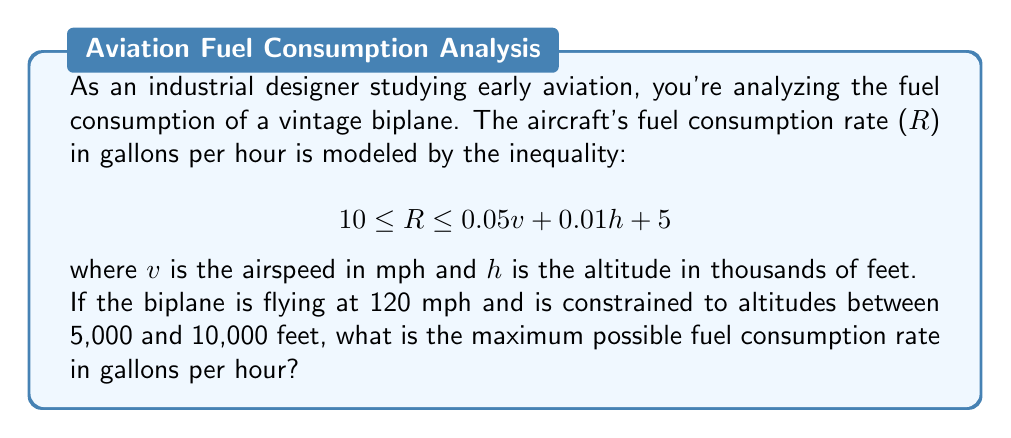Can you solve this math problem? To solve this problem, we need to follow these steps:

1) First, let's understand the given inequality:
   $$10 \leq R \leq 0.05v + 0.01h + 5$$

2) We're given that the airspeed $v = 120$ mph.

3) The altitude $h$ is between 5 and 10 thousand feet. To maximize fuel consumption, we should use the upper limit of 10,000 feet, or $h = 10$.

4) Let's substitute these values into the right side of the inequality:

   $$R \leq 0.05(120) + 0.01(10) + 5$$

5) Now let's calculate:
   
   $$R \leq 6 + 0.1 + 5$$
   $$R \leq 11.1$$

6) Remember, we also have the lower bound of 10 from the original inequality.

7) Therefore, the complete solution is:

   $$10 \leq R \leq 11.1$$

8) The question asks for the maximum possible fuel consumption rate, which is the upper bound of this inequality.
Answer: The maximum possible fuel consumption rate is 11.1 gallons per hour. 